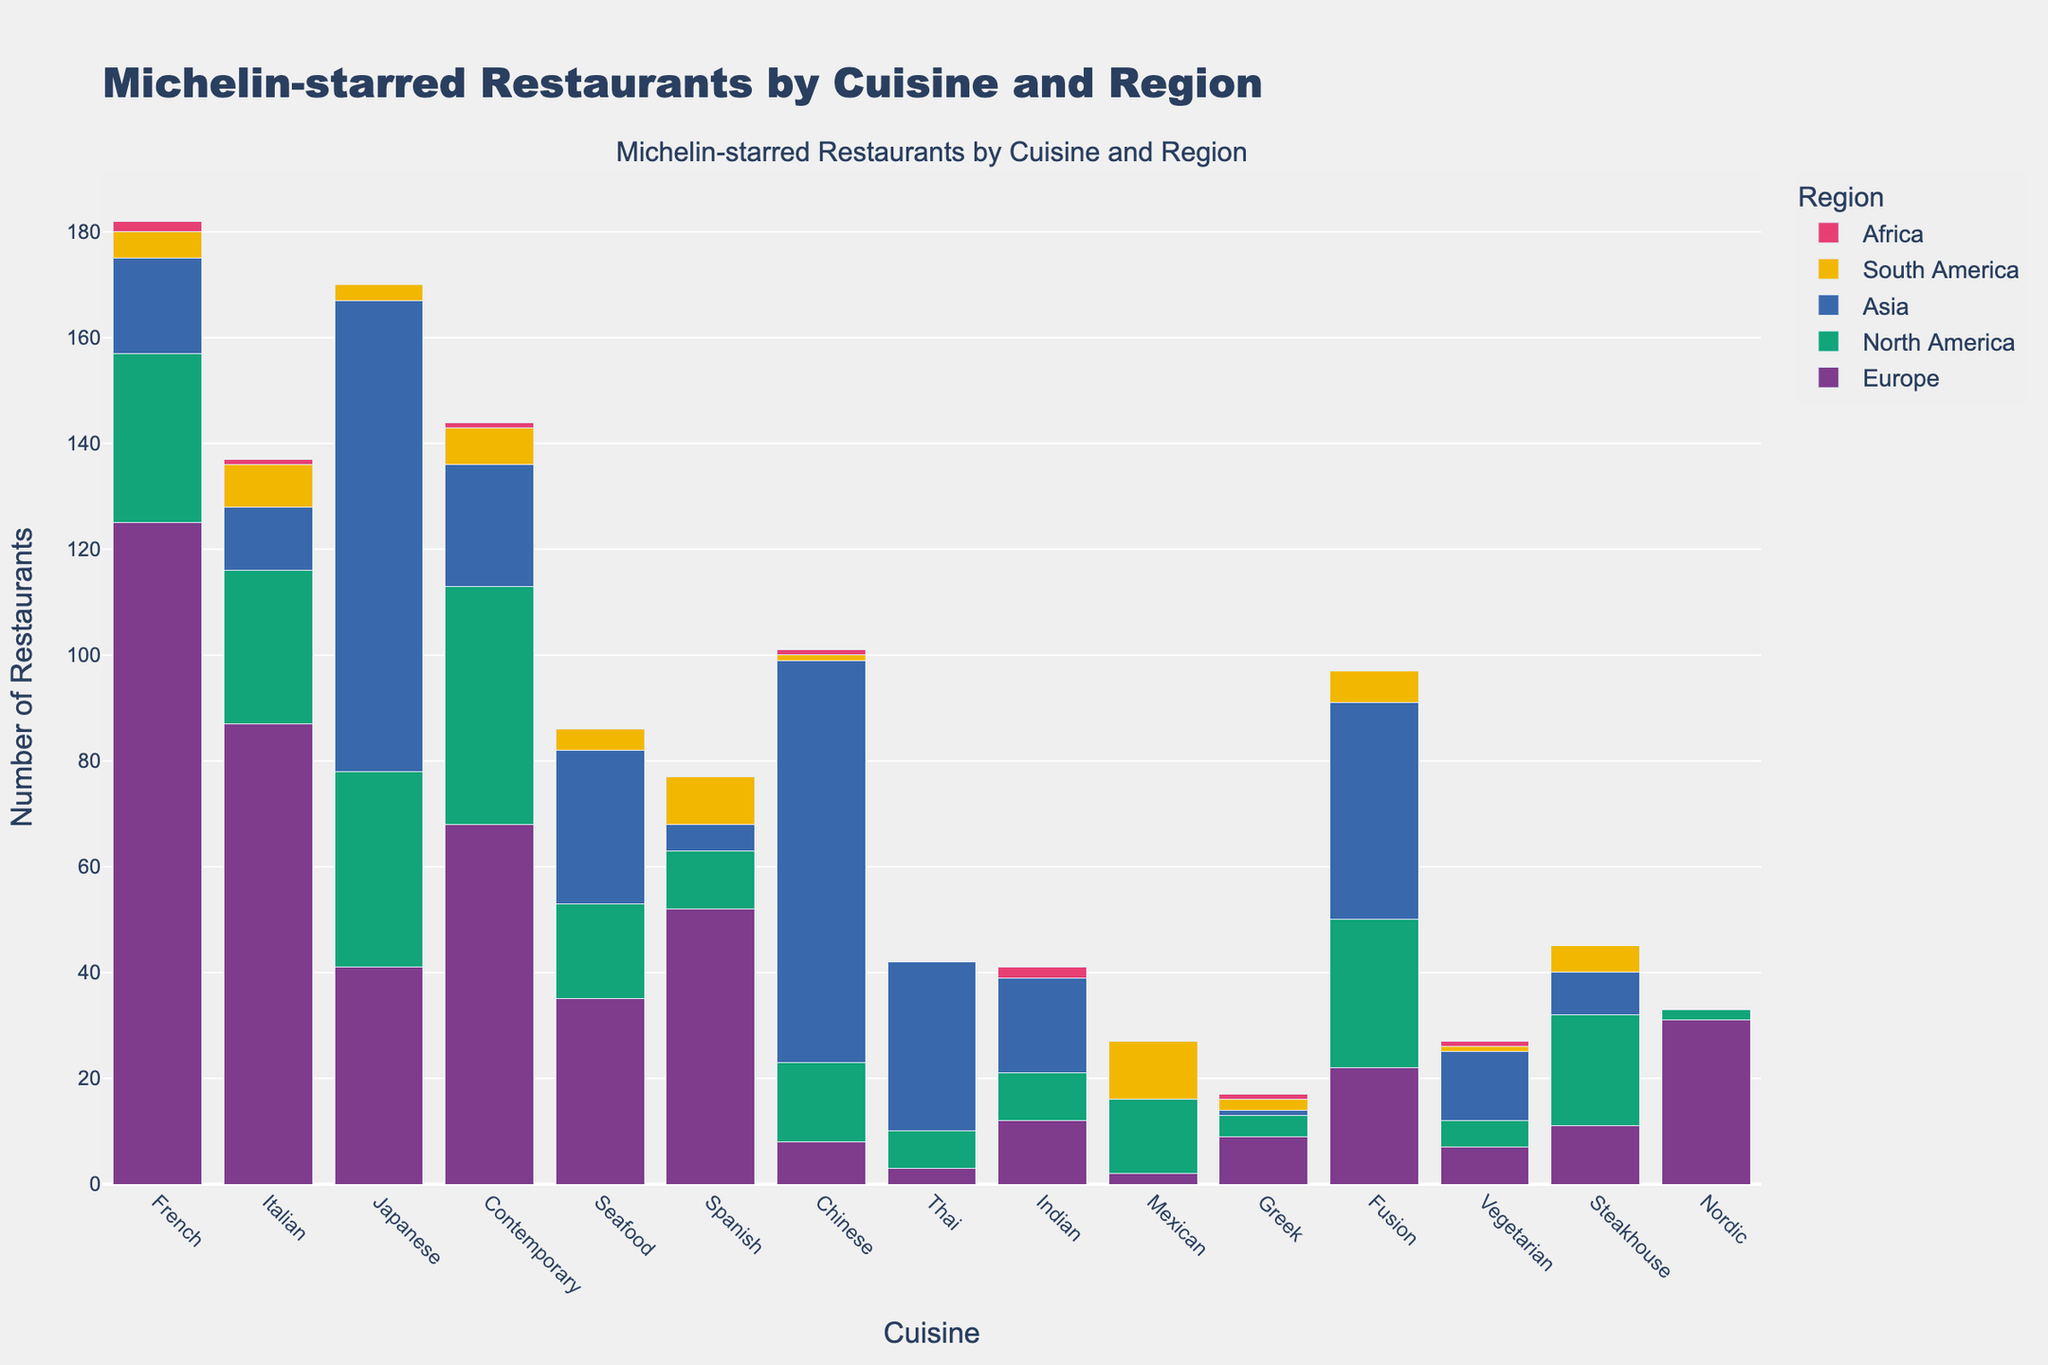Which cuisine has the highest number of Michelin-starred restaurants in North America? To find this, look at the bar heights for North America. The cuisine with the tallest bar is Japanese.
Answer: Japanese Which region has the least number of Japanese Michelin-starred restaurants? To find this, check the heights of the bars corresponding to Japanese cuisine in each region. Africa has no Japanese Michelin-starred restaurants, indicating the least number.
Answer: Africa How many more Michelin-starred French restaurants are there in Europe compared to Asia? Identify the bar height for French cuisine in Europe (125) and Asia (18). Subtract the number of restaurants in Asia from the number in Europe: 125 - 18 = 107.
Answer: 107 Which region has more Michelin-starred Italian restaurants, Europe or North America? Compare the heights of the bars for Italian cuisine in Europe (87) and North America (29). Europe has taller bars for Italian cuisine.
Answer: Europe What is the total number of Michelin-starred Chinese restaurants across all regions? Add the bar heights for Chinese cuisine in all regions: 8 (Europe) + 15 (North America) + 76 (Asia) + 1 (South America) + 1 (Africa) = 101.
Answer: 101 Which cuisine has the least representation in Michelin-starred restaurants in South America? Look at the bar heights for each cuisine in South America. Thai and Nordic cuisines both have the shortest bars with a height of 0.
Answer: Thai and Nordic What is the average number of Michelin-starred Seafood restaurants across Europe, North America, and Asia? Calculate the sum of Seafood restaurants in these regions: 35 (Europe) + 18 (North America) + 29 (Asia) = 82. Divide this by 3: 82 / 3 ≈ 27.33.
Answer: 27.33 Which cuisine has the second highest number of Michelin-starred restaurants in Asia? Look at the bar heights for all cuisines in Asia; Japanese cuisine has the highest, followed by Chinese.
Answer: Chinese How does the number of Mexican Michelin-starred restaurants in North America compare to Europe? Check the bar heights for Mexican cuisine in North America (14) and Europe (2). North America has more Mexican Michelin-starred restaurants.
Answer: North America By how much does the number of Michelin-starred Fusion restaurants in Asia exceed those in South America? Identify the bar heights for Fusion cuisine in Asia (41) and South America (6). Subtract South America's number from Asia's: 41 - 6 = 35.
Answer: 35 